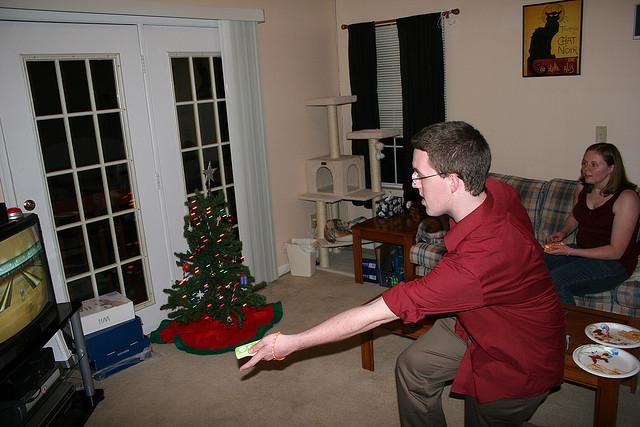What kind of game is the man playing? Please explain your reasoning. bowling. The television screen shows a ball and lanes. 